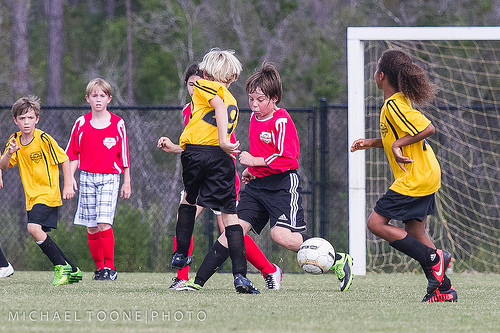<image>
Is there a ball in front of the child? Yes. The ball is positioned in front of the child, appearing closer to the camera viewpoint. 